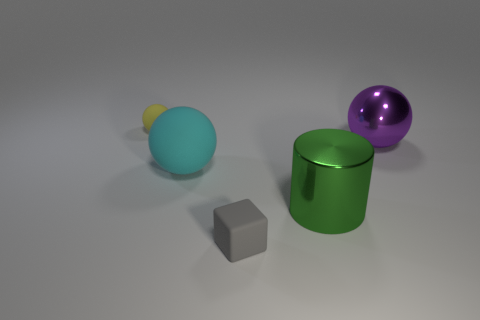Subtract 1 spheres. How many spheres are left? 2 Add 1 large balls. How many objects exist? 6 Subtract all spheres. How many objects are left? 2 Subtract all yellow rubber cylinders. Subtract all small spheres. How many objects are left? 4 Add 4 tiny gray blocks. How many tiny gray blocks are left? 5 Add 4 large red matte objects. How many large red matte objects exist? 4 Subtract 0 purple cubes. How many objects are left? 5 